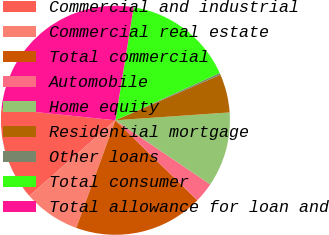<chart> <loc_0><loc_0><loc_500><loc_500><pie_chart><fcel>Commercial and industrial<fcel>Commercial real estate<fcel>Total commercial<fcel>Automobile<fcel>Home equity<fcel>Residential mortgage<fcel>Other loans<fcel>Total consumer<fcel>Total allowance for loan and<nl><fcel>13.11%<fcel>7.98%<fcel>18.24%<fcel>2.85%<fcel>10.55%<fcel>5.42%<fcel>0.26%<fcel>15.68%<fcel>25.91%<nl></chart> 